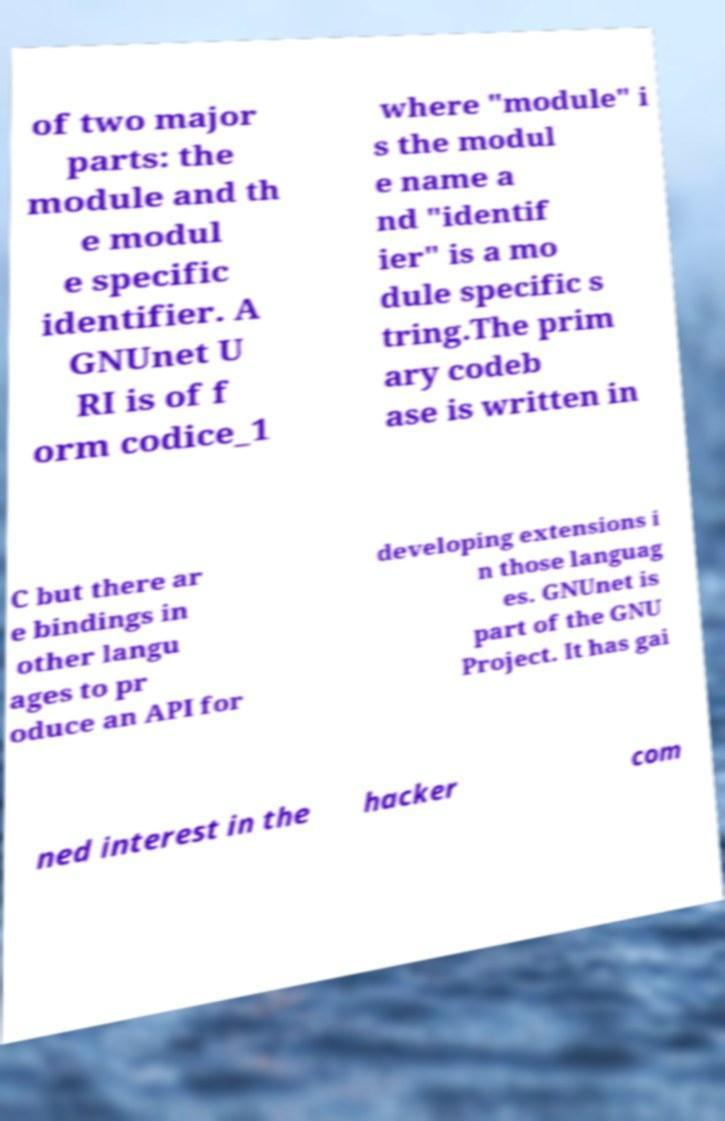What messages or text are displayed in this image? I need them in a readable, typed format. of two major parts: the module and th e modul e specific identifier. A GNUnet U RI is of f orm codice_1 where "module" i s the modul e name a nd "identif ier" is a mo dule specific s tring.The prim ary codeb ase is written in C but there ar e bindings in other langu ages to pr oduce an API for developing extensions i n those languag es. GNUnet is part of the GNU Project. It has gai ned interest in the hacker com 